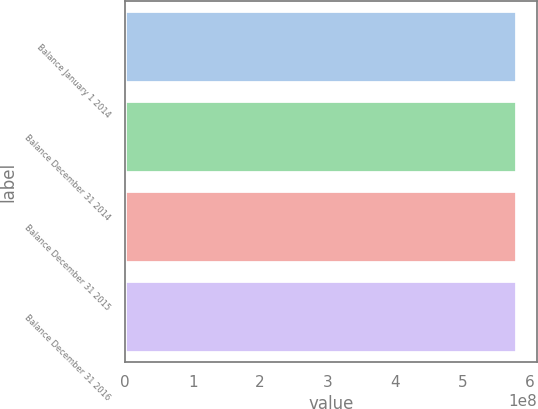<chart> <loc_0><loc_0><loc_500><loc_500><bar_chart><fcel>Balance January 1 2014<fcel>Balance December 31 2014<fcel>Balance December 31 2015<fcel>Balance December 31 2016<nl><fcel>5.81146e+08<fcel>5.81146e+08<fcel>5.81146e+08<fcel>5.81146e+08<nl></chart> 